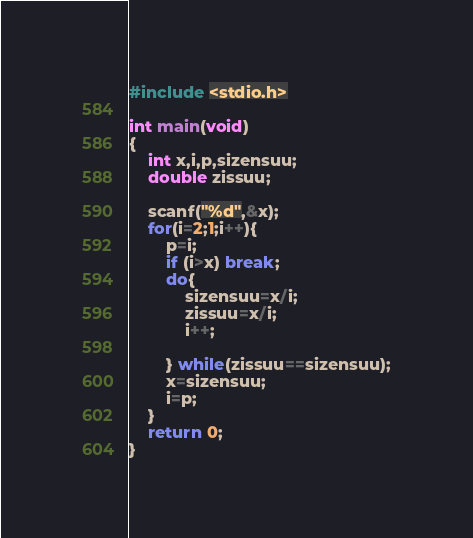Convert code to text. <code><loc_0><loc_0><loc_500><loc_500><_C_>#include <stdio.h>

int main(void)
{
    int x,i,p,sizensuu;
    double zissuu;

    scanf("%d",&x);
    for(i=2;1;i++){
        p=i;
        if (i>x) break;
        do{
            sizensuu=x/i;
            zissuu=x/i;
            i++;

        } while(zissuu==sizensuu);
        x=sizensuu;
        i=p;
    }
    return 0;
}</code> 